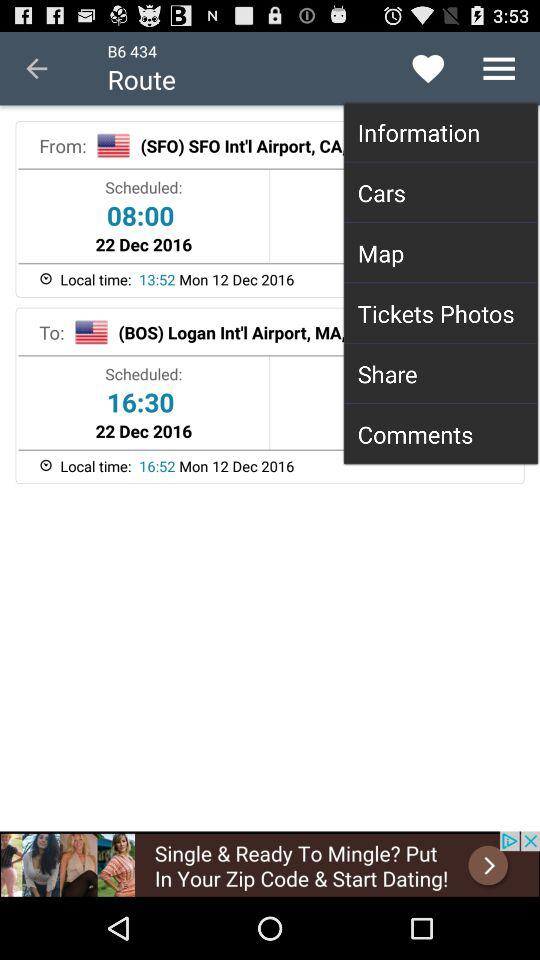What is the scheduled time for departure? The scheduled time for departure is 8:00. 